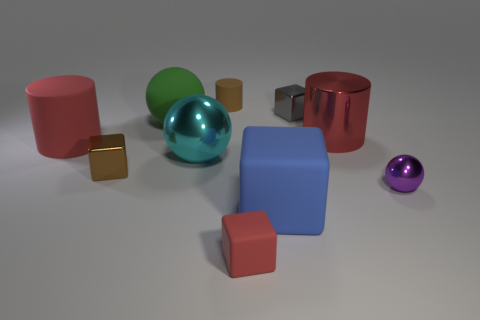Subtract all small purple balls. How many balls are left? 2 Subtract all cyan balls. How many balls are left? 2 Subtract 2 cylinders. How many cylinders are left? 1 Subtract all cylinders. How many objects are left? 7 Subtract all blue matte cubes. Subtract all big blocks. How many objects are left? 8 Add 6 tiny cubes. How many tiny cubes are left? 9 Add 7 tiny cylinders. How many tiny cylinders exist? 8 Subtract 1 brown cylinders. How many objects are left? 9 Subtract all blue balls. Subtract all cyan blocks. How many balls are left? 3 Subtract all green cylinders. How many yellow balls are left? 0 